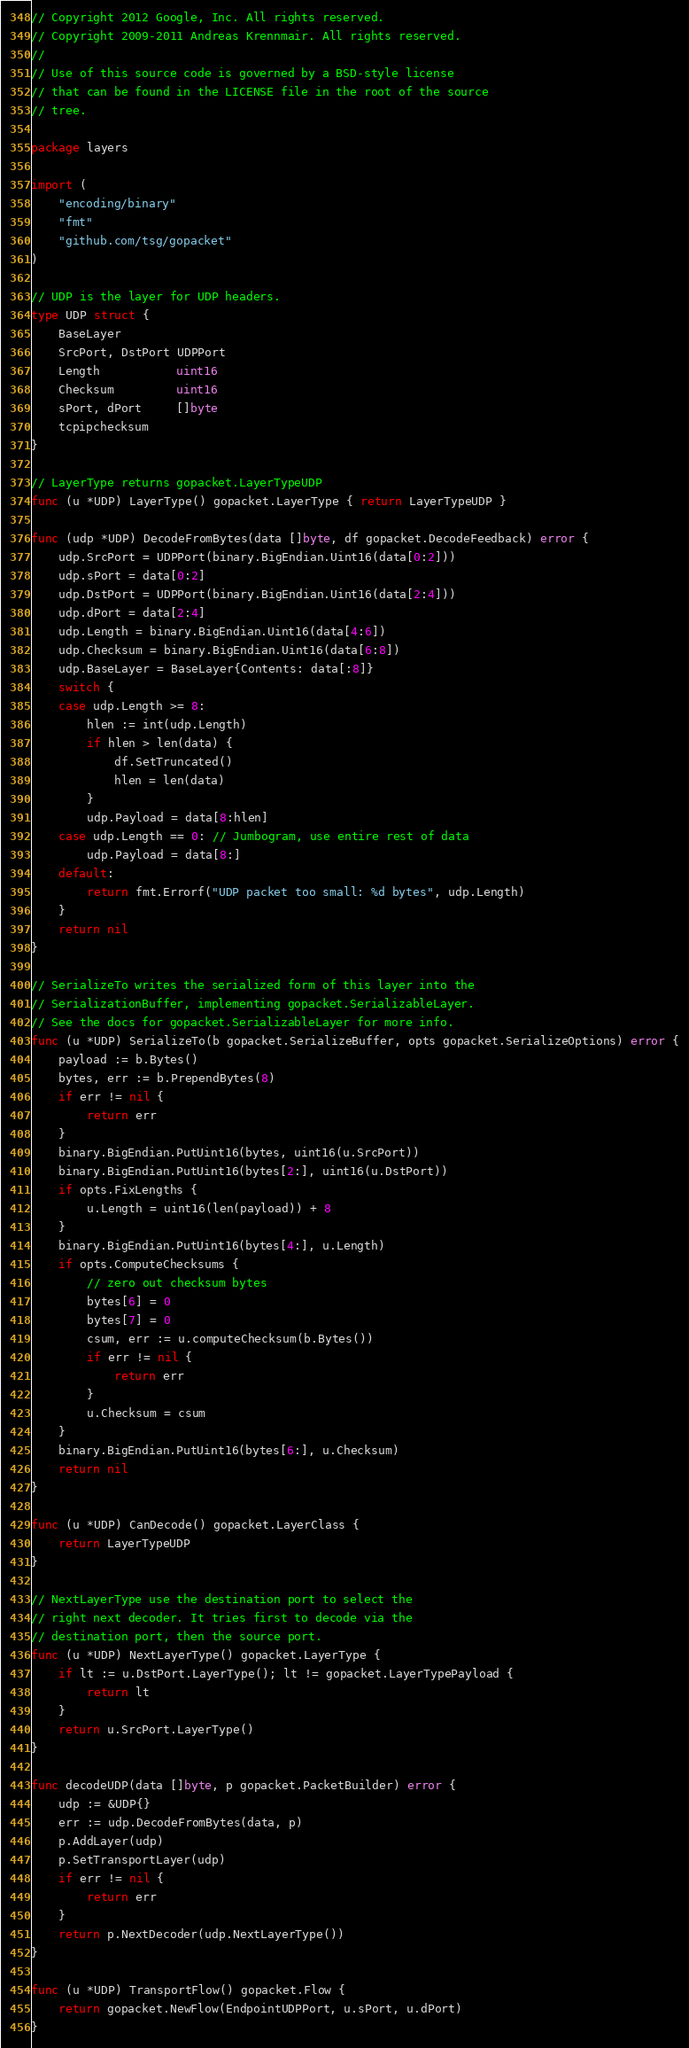<code> <loc_0><loc_0><loc_500><loc_500><_Go_>// Copyright 2012 Google, Inc. All rights reserved.
// Copyright 2009-2011 Andreas Krennmair. All rights reserved.
//
// Use of this source code is governed by a BSD-style license
// that can be found in the LICENSE file in the root of the source
// tree.

package layers

import (
	"encoding/binary"
	"fmt"
	"github.com/tsg/gopacket"
)

// UDP is the layer for UDP headers.
type UDP struct {
	BaseLayer
	SrcPort, DstPort UDPPort
	Length           uint16
	Checksum         uint16
	sPort, dPort     []byte
	tcpipchecksum
}

// LayerType returns gopacket.LayerTypeUDP
func (u *UDP) LayerType() gopacket.LayerType { return LayerTypeUDP }

func (udp *UDP) DecodeFromBytes(data []byte, df gopacket.DecodeFeedback) error {
	udp.SrcPort = UDPPort(binary.BigEndian.Uint16(data[0:2]))
	udp.sPort = data[0:2]
	udp.DstPort = UDPPort(binary.BigEndian.Uint16(data[2:4]))
	udp.dPort = data[2:4]
	udp.Length = binary.BigEndian.Uint16(data[4:6])
	udp.Checksum = binary.BigEndian.Uint16(data[6:8])
	udp.BaseLayer = BaseLayer{Contents: data[:8]}
	switch {
	case udp.Length >= 8:
		hlen := int(udp.Length)
		if hlen > len(data) {
			df.SetTruncated()
			hlen = len(data)
		}
		udp.Payload = data[8:hlen]
	case udp.Length == 0: // Jumbogram, use entire rest of data
		udp.Payload = data[8:]
	default:
		return fmt.Errorf("UDP packet too small: %d bytes", udp.Length)
	}
	return nil
}

// SerializeTo writes the serialized form of this layer into the
// SerializationBuffer, implementing gopacket.SerializableLayer.
// See the docs for gopacket.SerializableLayer for more info.
func (u *UDP) SerializeTo(b gopacket.SerializeBuffer, opts gopacket.SerializeOptions) error {
	payload := b.Bytes()
	bytes, err := b.PrependBytes(8)
	if err != nil {
		return err
	}
	binary.BigEndian.PutUint16(bytes, uint16(u.SrcPort))
	binary.BigEndian.PutUint16(bytes[2:], uint16(u.DstPort))
	if opts.FixLengths {
		u.Length = uint16(len(payload)) + 8
	}
	binary.BigEndian.PutUint16(bytes[4:], u.Length)
	if opts.ComputeChecksums {
		// zero out checksum bytes
		bytes[6] = 0
		bytes[7] = 0
		csum, err := u.computeChecksum(b.Bytes())
		if err != nil {
			return err
		}
		u.Checksum = csum
	}
	binary.BigEndian.PutUint16(bytes[6:], u.Checksum)
	return nil
}

func (u *UDP) CanDecode() gopacket.LayerClass {
	return LayerTypeUDP
}

// NextLayerType use the destination port to select the
// right next decoder. It tries first to decode via the
// destination port, then the source port.
func (u *UDP) NextLayerType() gopacket.LayerType {
	if lt := u.DstPort.LayerType(); lt != gopacket.LayerTypePayload {
		return lt
	}
	return u.SrcPort.LayerType()
}

func decodeUDP(data []byte, p gopacket.PacketBuilder) error {
	udp := &UDP{}
	err := udp.DecodeFromBytes(data, p)
	p.AddLayer(udp)
	p.SetTransportLayer(udp)
	if err != nil {
		return err
	}
	return p.NextDecoder(udp.NextLayerType())
}

func (u *UDP) TransportFlow() gopacket.Flow {
	return gopacket.NewFlow(EndpointUDPPort, u.sPort, u.dPort)
}
</code> 